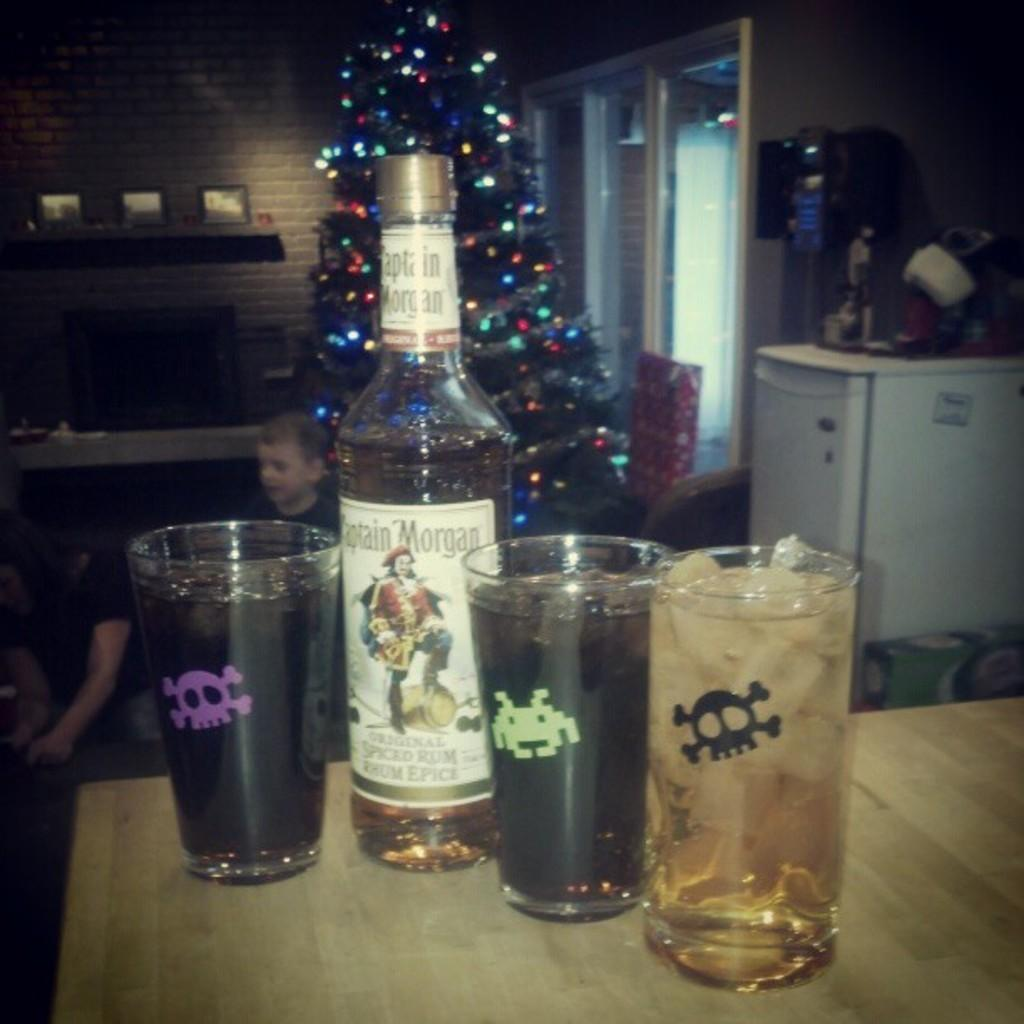<image>
Present a compact description of the photo's key features. Three glasses filled with coke and rum with a bottle of Captain Morgan's spiced rum in the middle. 